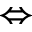Convert formula to latex. <formula><loc_0><loc_0><loc_500><loc_500>\Leftrightarrow</formula> 